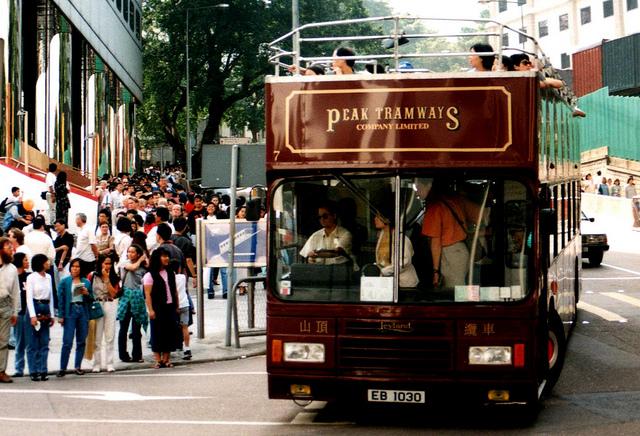Is the top of this vehicle open?
Answer briefly. Yes. What bus is the lady waiting for?
Give a very brief answer. Peak tramways. What is the name of the tramway company?
Answer briefly. Peak tramways. Is this a double deckered bus?
Keep it brief. Yes. 